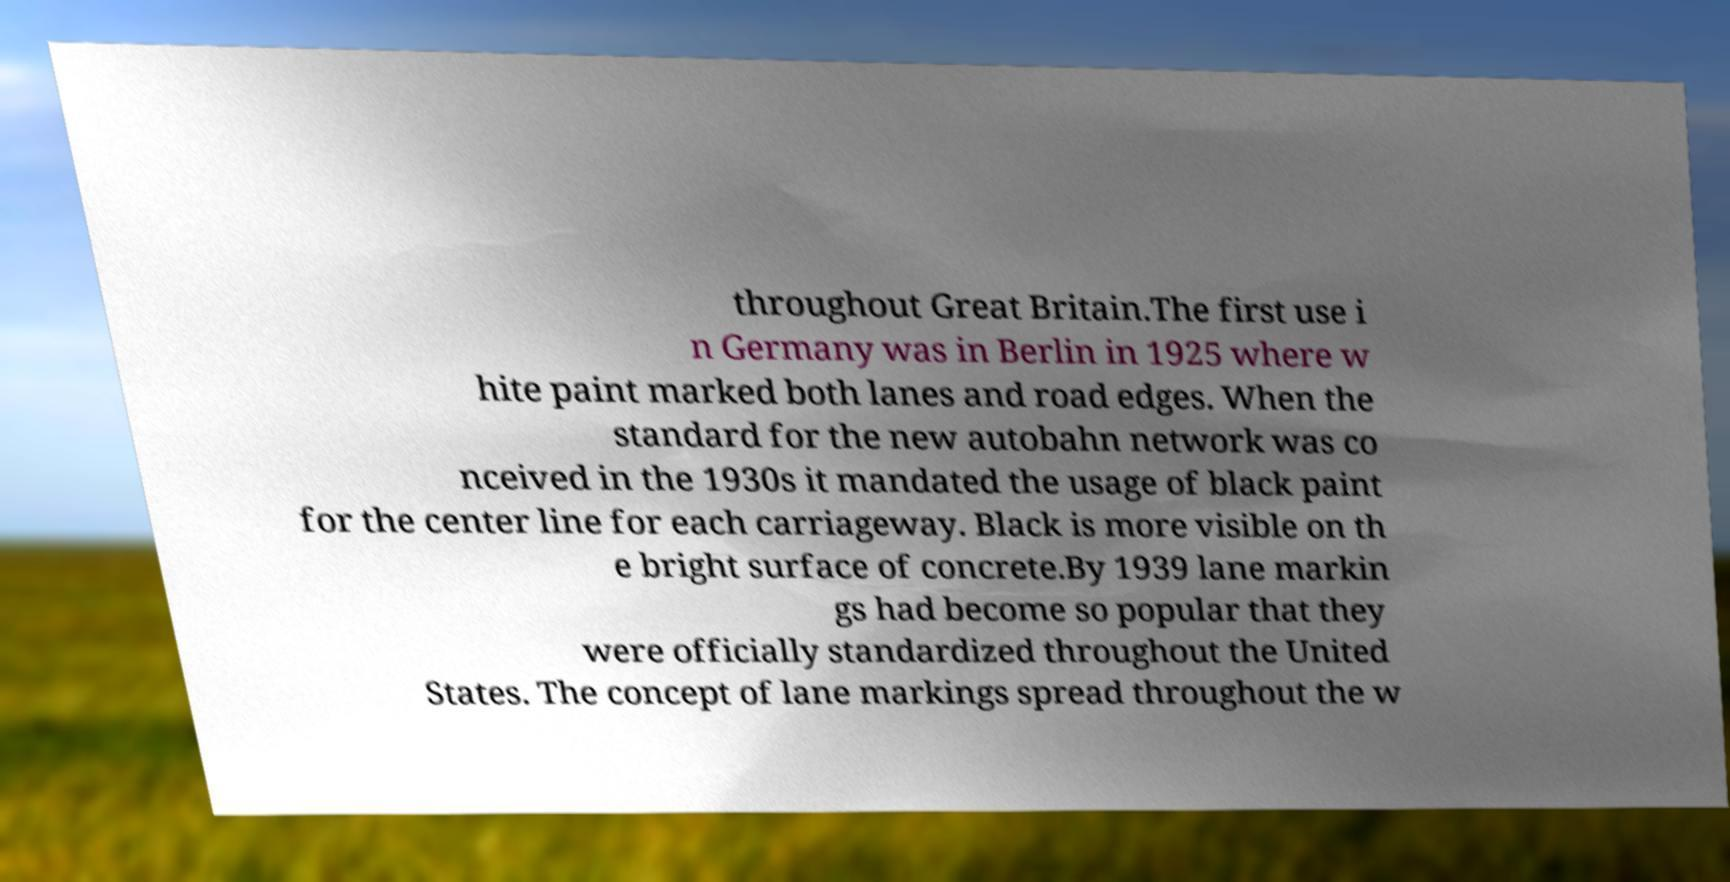I need the written content from this picture converted into text. Can you do that? throughout Great Britain.The first use i n Germany was in Berlin in 1925 where w hite paint marked both lanes and road edges. When the standard for the new autobahn network was co nceived in the 1930s it mandated the usage of black paint for the center line for each carriageway. Black is more visible on th e bright surface of concrete.By 1939 lane markin gs had become so popular that they were officially standardized throughout the United States. The concept of lane markings spread throughout the w 